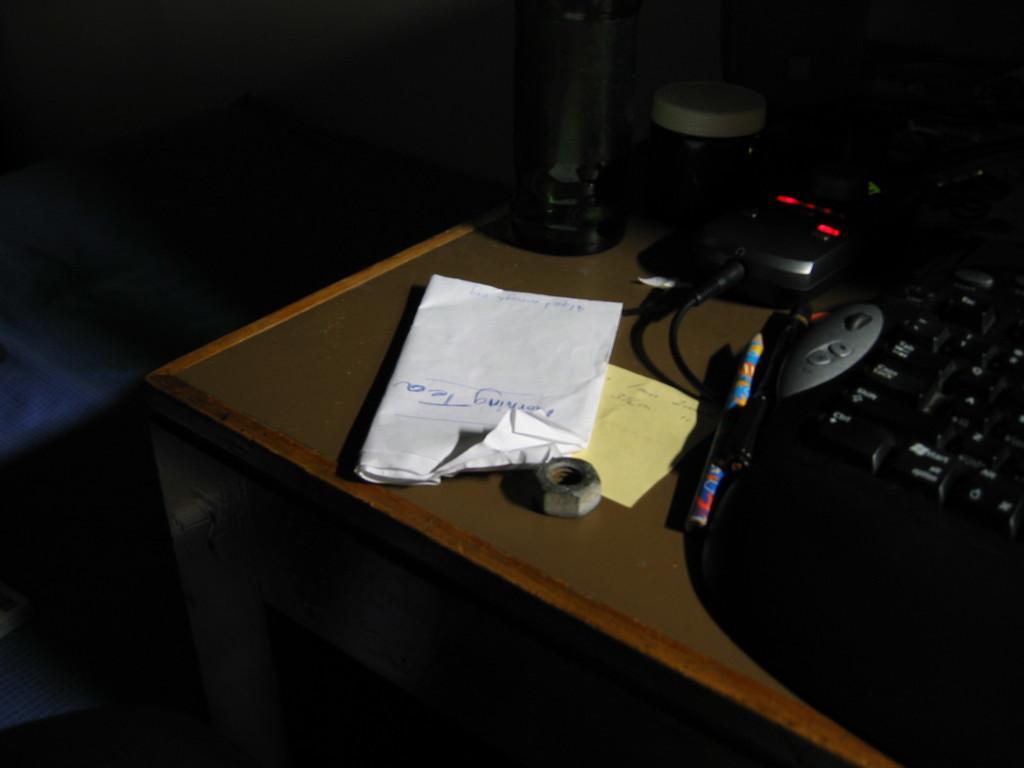How would you summarize this image in a sentence or two? In a room there is a table where keyboard, pens, papers and one water bottle and nut and a box are present. 